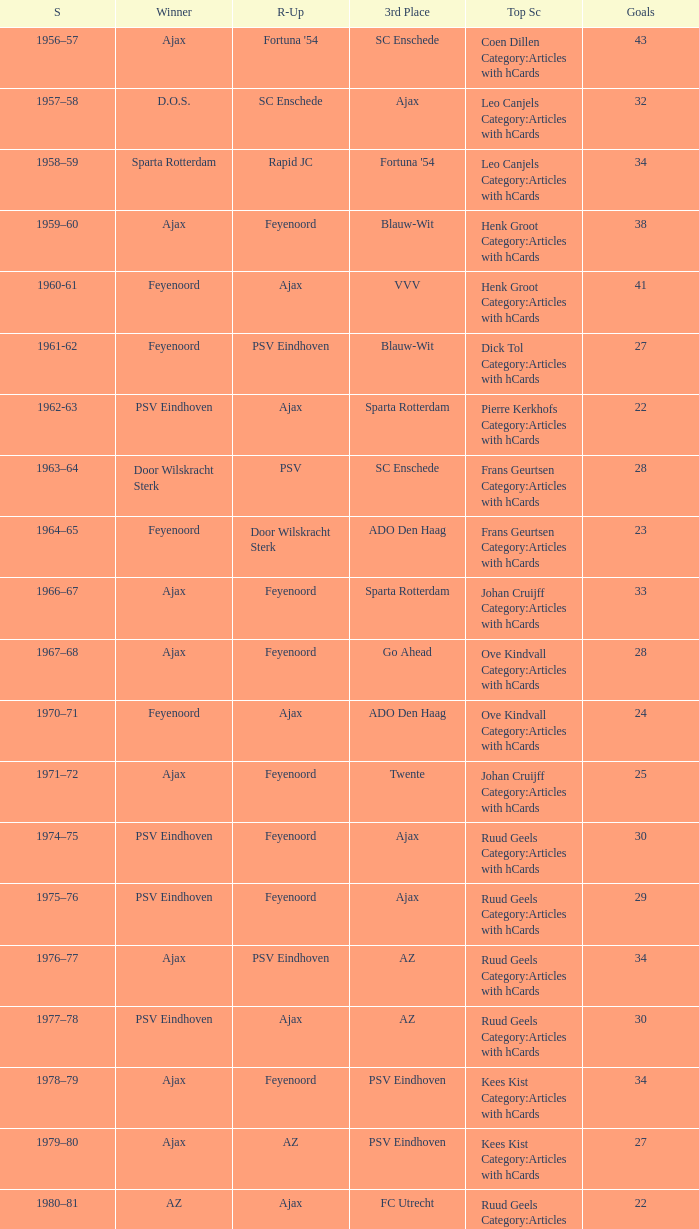Could you parse the entire table as a dict? {'header': ['S', 'Winner', 'R-Up', '3rd Place', 'Top Sc', 'Goals'], 'rows': [['1956–57', 'Ajax', "Fortuna '54", 'SC Enschede', 'Coen Dillen Category:Articles with hCards', '43'], ['1957–58', 'D.O.S.', 'SC Enschede', 'Ajax', 'Leo Canjels Category:Articles with hCards', '32'], ['1958–59', 'Sparta Rotterdam', 'Rapid JC', "Fortuna '54", 'Leo Canjels Category:Articles with hCards', '34'], ['1959–60', 'Ajax', 'Feyenoord', 'Blauw-Wit', 'Henk Groot Category:Articles with hCards', '38'], ['1960-61', 'Feyenoord', 'Ajax', 'VVV', 'Henk Groot Category:Articles with hCards', '41'], ['1961-62', 'Feyenoord', 'PSV Eindhoven', 'Blauw-Wit', 'Dick Tol Category:Articles with hCards', '27'], ['1962-63', 'PSV Eindhoven', 'Ajax', 'Sparta Rotterdam', 'Pierre Kerkhofs Category:Articles with hCards', '22'], ['1963–64', 'Door Wilskracht Sterk', 'PSV', 'SC Enschede', 'Frans Geurtsen Category:Articles with hCards', '28'], ['1964–65', 'Feyenoord', 'Door Wilskracht Sterk', 'ADO Den Haag', 'Frans Geurtsen Category:Articles with hCards', '23'], ['1966–67', 'Ajax', 'Feyenoord', 'Sparta Rotterdam', 'Johan Cruijff Category:Articles with hCards', '33'], ['1967–68', 'Ajax', 'Feyenoord', 'Go Ahead', 'Ove Kindvall Category:Articles with hCards', '28'], ['1970–71', 'Feyenoord', 'Ajax', 'ADO Den Haag', 'Ove Kindvall Category:Articles with hCards', '24'], ['1971–72', 'Ajax', 'Feyenoord', 'Twente', 'Johan Cruijff Category:Articles with hCards', '25'], ['1974–75', 'PSV Eindhoven', 'Feyenoord', 'Ajax', 'Ruud Geels Category:Articles with hCards', '30'], ['1975–76', 'PSV Eindhoven', 'Feyenoord', 'Ajax', 'Ruud Geels Category:Articles with hCards', '29'], ['1976–77', 'Ajax', 'PSV Eindhoven', 'AZ', 'Ruud Geels Category:Articles with hCards', '34'], ['1977–78', 'PSV Eindhoven', 'Ajax', 'AZ', 'Ruud Geels Category:Articles with hCards', '30'], ['1978–79', 'Ajax', 'Feyenoord', 'PSV Eindhoven', 'Kees Kist Category:Articles with hCards', '34'], ['1979–80', 'Ajax', 'AZ', 'PSV Eindhoven', 'Kees Kist Category:Articles with hCards', '27'], ['1980–81', 'AZ', 'Ajax', 'FC Utrecht', 'Ruud Geels Category:Articles with hCards', '22'], ['1981-82', 'Ajax', 'PSV Eindhoven', 'AZ', 'Wim Kieft Category:Articles with hCards', '32'], ['1982-83', 'Ajax', 'Feyenoord', 'PSV Eindhoven', 'Peter Houtman Category:Articles with hCards', '30'], ['1983-84', 'Feyenoord', 'PSV Eindhoven', 'Ajax', 'Marco van Basten Category:Articles with hCards', '28'], ['1984-85', 'Ajax', 'PSV Eindhoven', 'Feyenoord', 'Marco van Basten Category:Articles with hCards', '22'], ['1985-86', 'PSV Eindhoven', 'Ajax', 'Feyenoord', 'Marco van Basten Category:Articles with hCards', '37'], ['1986-87', 'PSV Eindhoven', 'Ajax', 'Feyenoord', 'Marco van Basten Category:Articles with hCards', '31'], ['1987-88', 'PSV Eindhoven', 'Ajax', 'Twente', 'Wim Kieft Category:Articles with hCards', '29'], ['1988–89', 'PSV Eindhoven', 'Ajax', 'Twente', 'Romário', '19'], ['1989-90', 'Ajax', 'PSV Eindhoven', 'Twente', 'Romário', '23'], ['1990–91', 'PSV Eindhoven', 'Ajax', 'FC Groningen', 'Romário Dennis Bergkamp', '25'], ['1991–92', 'PSV Eindhoven', 'Ajax', 'Feyenoord', 'Dennis Bergkamp Category:Articles with hCards', '22'], ['1992–93', 'Feyenoord', 'PSV Eindhoven', 'Ajax', 'Dennis Bergkamp Category:Articles with hCards', '26'], ['1993–94', 'Ajax', 'Feyenoord', 'PSV Eindhoven', 'Jari Litmanen Category:Articles with hCards', '26'], ['1994–95', 'Ajax', 'Roda JC', 'PSV Eindhoven', 'Ronaldo', '30'], ['1995–96', 'Ajax', 'PSV Eindhoven', 'Feyenoord', 'Luc Nilis Category:Articles with hCards', '21'], ['1996–97', 'PSV Eindhoven', 'Feyenoord', 'Twente', 'Luc Nilis Category:Articles with hCards', '21'], ['1997–98', 'Ajax', 'PSV Eindhoven', 'Vitesse', 'Nikos Machlas Category:Articles with hCards', '34'], ['1998–99', 'Feyenoord', 'Willem II', 'PSV Eindhoven', 'Ruud van Nistelrooy Category:Articles with hCards', '31'], ['1999–2000', 'PSV Eindhoven', 'Heerenveen', 'Feyenoord', 'Ruud van Nistelrooy Category:Articles with hCards', '29'], ['2000–01', 'PSV Eindhoven', 'Feyenoord', 'Ajax', 'Mateja Kežman Category:Articles with hCards', '24'], ['2001–02', 'Ajax', 'PSV Eindhoven', 'Feyenoord', 'Pierre van Hooijdonk Category:Articles with hCards', '24'], ['2002-03', 'PSV Eindhoven', 'Ajax', 'Feyenoord', 'Mateja Kežman Category:Articles with hCards', '35'], ['2003-04', 'Ajax', 'PSV Eindhoven', 'Feyenoord', 'Mateja Kežman Category:Articles with hCards', '31'], ['2004-05', 'PSV Eindhoven', 'Ajax', 'AZ', 'Dirk Kuyt Category:Articles with hCards', '29'], ['2005-06', 'PSV Eindhoven', 'AZ', 'Feyenoord', 'Klaas-Jan Huntelaar Category:Articles with hCards', '33'], ['2006-07', 'PSV Eindhoven', 'Ajax', 'AZ', 'Afonso Alves Category:Articles with hCards', '34'], ['2007-08', 'PSV Eindhoven', 'Ajax', 'NAC Breda', 'Klaas-Jan Huntelaar Category:Articles with hCards', '33'], ['2008-09', 'AZ', 'Twente', 'Ajax', 'Mounir El Hamdaoui Category:Articles with hCards', '23'], ['2009-10', 'Twente', 'Ajax', 'PSV Eindhoven', 'Luis Suárez Category:Articles with hCards', '35'], ['2010-11', 'Ajax', 'Twente', 'PSV Eindhoven', 'Björn Vleminckx Category:Articles with hCards', '23'], ['2011-12', 'Ajax', 'Feyenoord', 'PSV Eindhoven', 'Bas Dost Category:Articles with hCards', '32']]} When nac breda came in third place and psv eindhoven was the winner who is the top scorer? Klaas-Jan Huntelaar Category:Articles with hCards. 